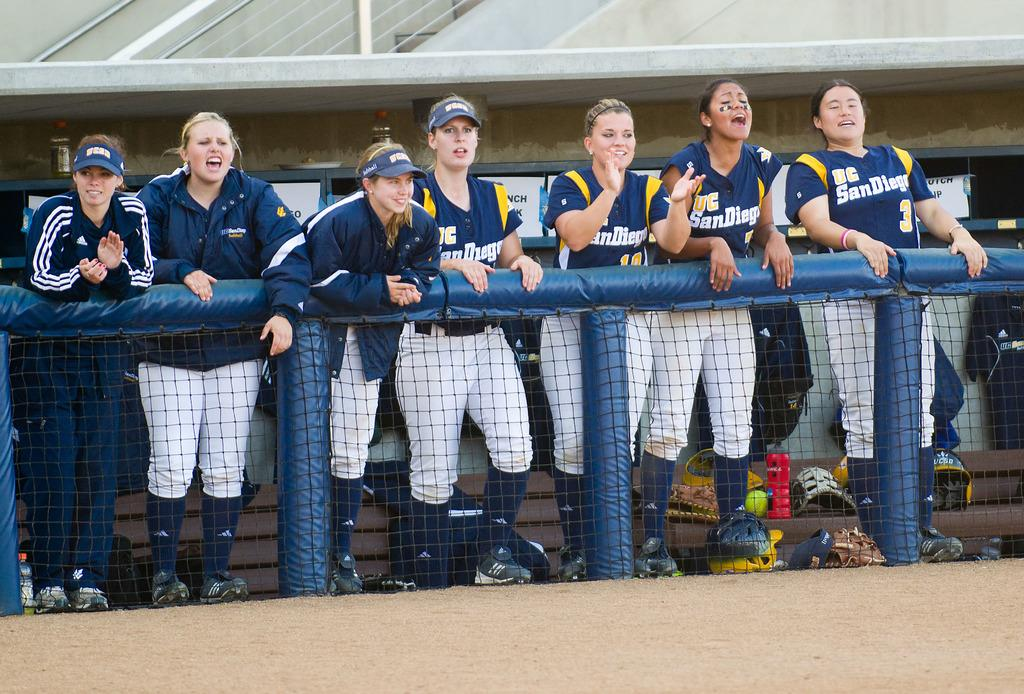Provide a one-sentence caption for the provided image. Girls softball players in blue jerseys from San Diego. 